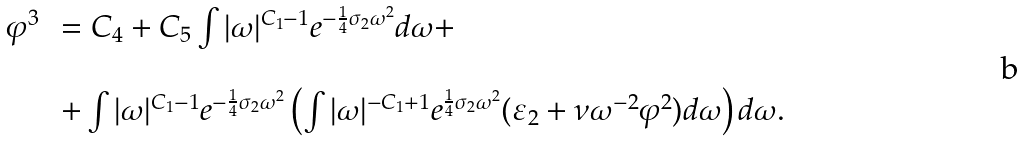Convert formula to latex. <formula><loc_0><loc_0><loc_500><loc_500>\begin{array} { l l } \varphi ^ { 3 } \, & = C _ { 4 } + C _ { 5 } \int | \omega | ^ { C _ { 1 } - 1 } e ^ { - \frac { 1 } { 4 } \sigma _ { 2 } \omega ^ { 2 } } d \omega + \\ \\ & + \int | \omega | ^ { C _ { 1 } - 1 } e ^ { - \frac { 1 } { 4 } \sigma _ { 2 } \omega ^ { 2 } } \left ( \int | \omega | ^ { - C _ { 1 } + 1 } e ^ { \frac { 1 } { 4 } \sigma _ { 2 } \omega ^ { 2 } } ( \varepsilon _ { 2 } + \nu \omega ^ { - 2 } \varphi ^ { 2 } ) d \omega \right ) d \omega . \end{array}</formula> 